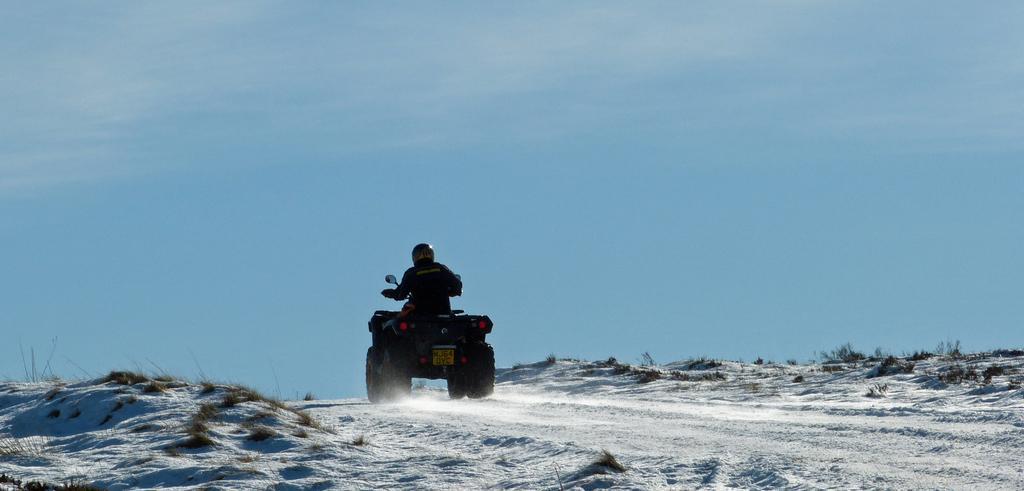Please provide a concise description of this image. In this image I can see a person on the vehicle. I can see the grass. In the background, I can see the clouds in the sky. 